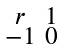Convert formula to latex. <formula><loc_0><loc_0><loc_500><loc_500>\begin{smallmatrix} r & 1 \\ - 1 & 0 \end{smallmatrix}</formula> 